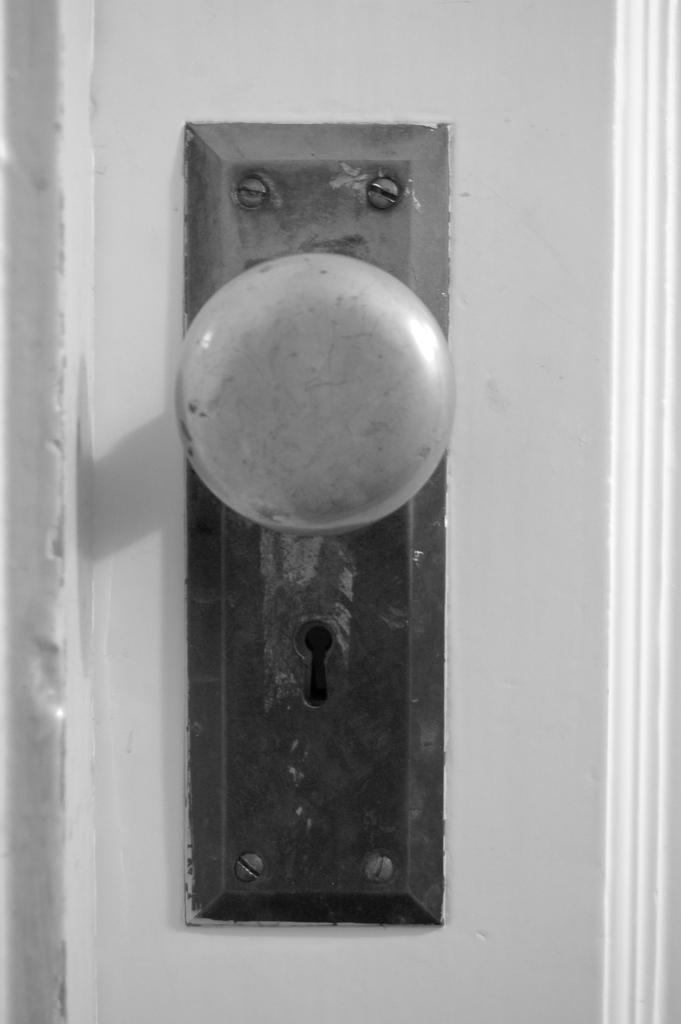What object is in the image that is used for locking and unlocking a door? There is a door lock handle in the image. Is the door lock handle attached to anything? Yes, the door lock handle is fixed to a door. What feature is present on the door lock handle for inserting a key? There is a keyhole in the image. What color is the door that the door lock handle is attached to? The door is white in color. Can you tell me how many credit cards are placed on the hat in the yard in the image? There is no hat, yard, or credit cards present in the image; it only features a door lock handle and a door. 